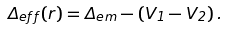Convert formula to latex. <formula><loc_0><loc_0><loc_500><loc_500>\Delta _ { e f f } ( r ) = \Delta _ { e m } - ( V _ { 1 } - V _ { 2 } ) \, .</formula> 